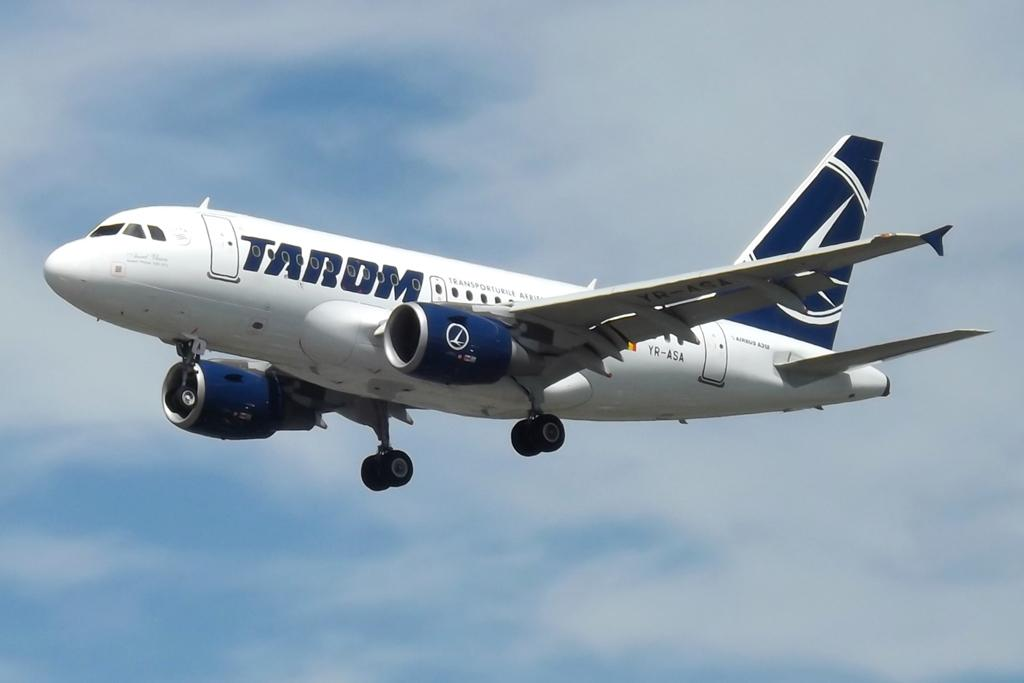<image>
Summarize the visual content of the image. A Tarom airplane flying in the blue sky 